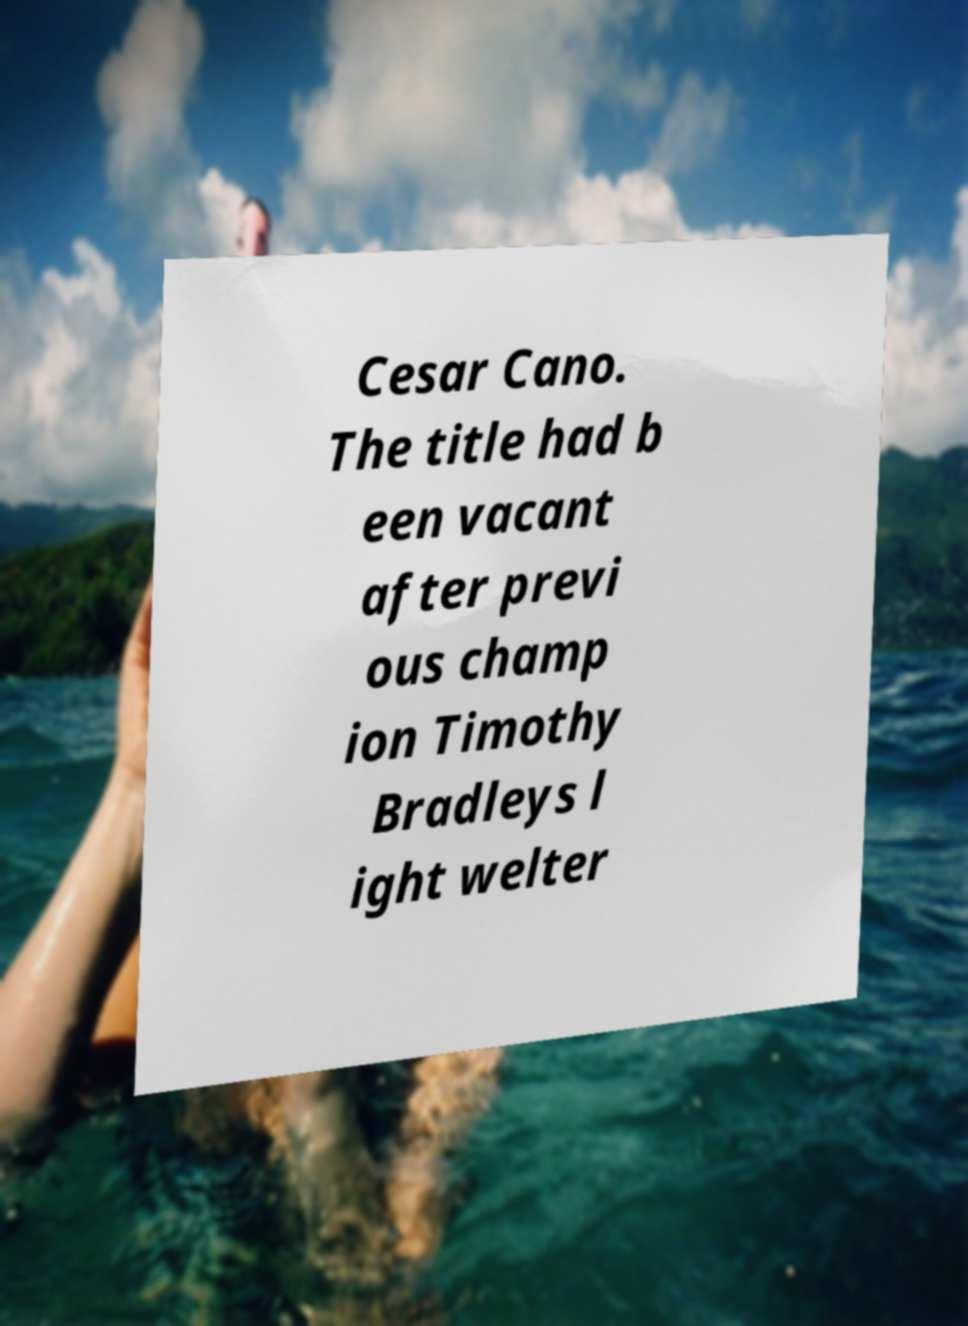There's text embedded in this image that I need extracted. Can you transcribe it verbatim? Cesar Cano. The title had b een vacant after previ ous champ ion Timothy Bradleys l ight welter 